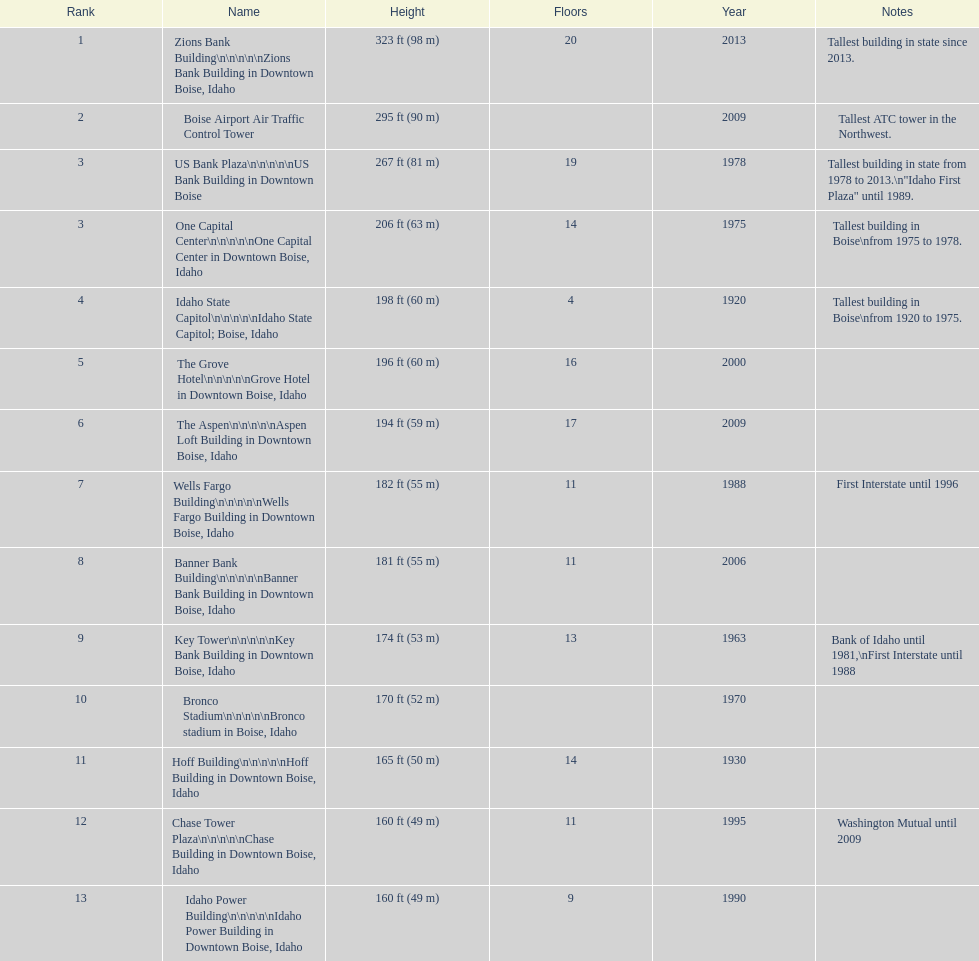How tall (in meters) is the tallest building? 98 m. 